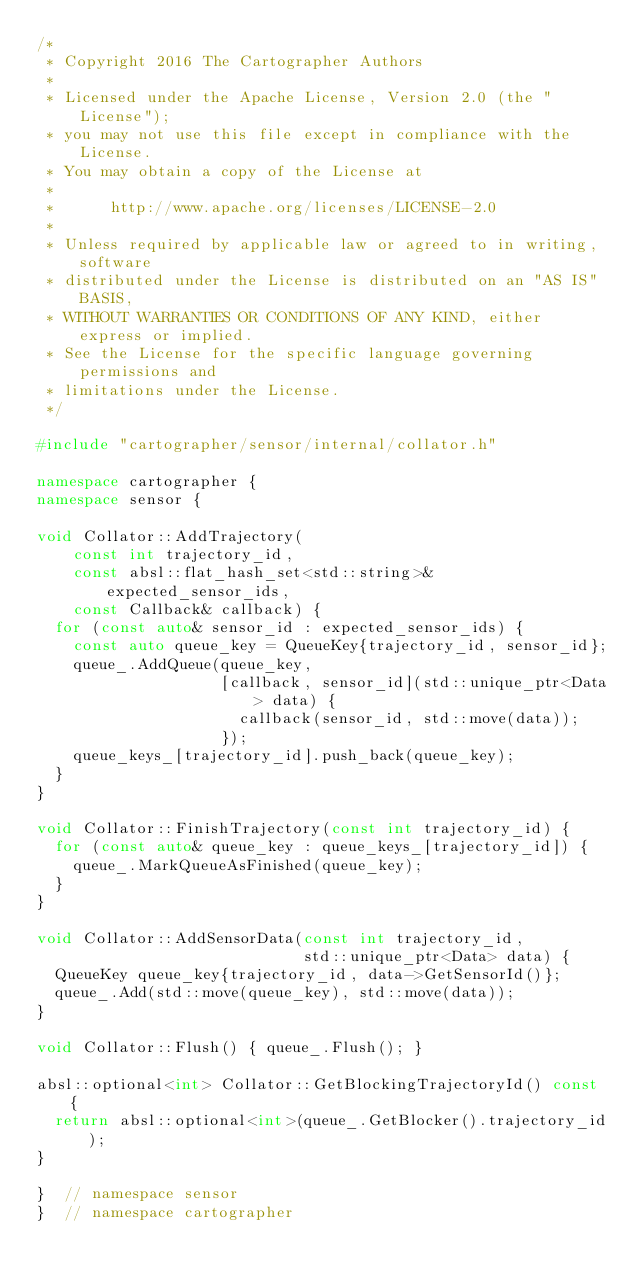Convert code to text. <code><loc_0><loc_0><loc_500><loc_500><_C++_>/*
 * Copyright 2016 The Cartographer Authors
 *
 * Licensed under the Apache License, Version 2.0 (the "License");
 * you may not use this file except in compliance with the License.
 * You may obtain a copy of the License at
 *
 *      http://www.apache.org/licenses/LICENSE-2.0
 *
 * Unless required by applicable law or agreed to in writing, software
 * distributed under the License is distributed on an "AS IS" BASIS,
 * WITHOUT WARRANTIES OR CONDITIONS OF ANY KIND, either express or implied.
 * See the License for the specific language governing permissions and
 * limitations under the License.
 */

#include "cartographer/sensor/internal/collator.h"

namespace cartographer {
namespace sensor {

void Collator::AddTrajectory(
    const int trajectory_id,
    const absl::flat_hash_set<std::string>& expected_sensor_ids,
    const Callback& callback) {
  for (const auto& sensor_id : expected_sensor_ids) {
    const auto queue_key = QueueKey{trajectory_id, sensor_id};
    queue_.AddQueue(queue_key,
                    [callback, sensor_id](std::unique_ptr<Data> data) {
                      callback(sensor_id, std::move(data));
                    });
    queue_keys_[trajectory_id].push_back(queue_key);
  }
}

void Collator::FinishTrajectory(const int trajectory_id) {
  for (const auto& queue_key : queue_keys_[trajectory_id]) {
    queue_.MarkQueueAsFinished(queue_key);
  }
}

void Collator::AddSensorData(const int trajectory_id,
                             std::unique_ptr<Data> data) {
  QueueKey queue_key{trajectory_id, data->GetSensorId()};
  queue_.Add(std::move(queue_key), std::move(data));
}

void Collator::Flush() { queue_.Flush(); }

absl::optional<int> Collator::GetBlockingTrajectoryId() const {
  return absl::optional<int>(queue_.GetBlocker().trajectory_id);
}

}  // namespace sensor
}  // namespace cartographer
</code> 